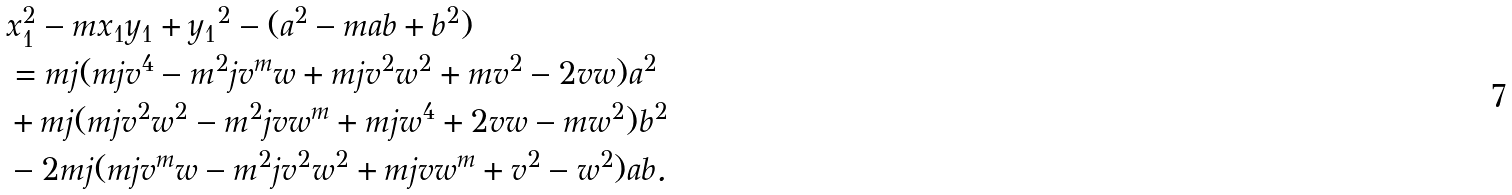Convert formula to latex. <formula><loc_0><loc_0><loc_500><loc_500>& x _ { 1 } ^ { 2 } - m x _ { 1 } y _ { 1 } + { y _ { 1 } } ^ { 2 } - ( a ^ { 2 } - m a b + b ^ { 2 } ) \\ & = m j ( m j v ^ { 4 } - m ^ { 2 } j v ^ { m } w + m j v ^ { 2 } w ^ { 2 } + m v ^ { 2 } - 2 v w ) a ^ { 2 } \\ & + m j ( m j v ^ { 2 } w ^ { 2 } - m ^ { 2 } j v w ^ { m } + m j w ^ { 4 } + 2 v w - m w ^ { 2 } ) b ^ { 2 } \\ & - 2 m j ( m j v ^ { m } w - m ^ { 2 } j v ^ { 2 } w ^ { 2 } + m j v w ^ { m } + v ^ { 2 } - w ^ { 2 } ) a b .</formula> 